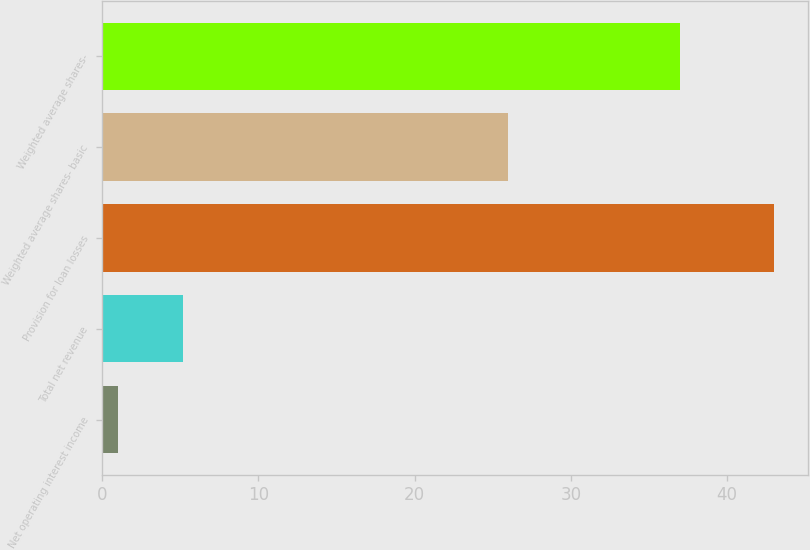Convert chart to OTSL. <chart><loc_0><loc_0><loc_500><loc_500><bar_chart><fcel>Net operating interest income<fcel>Total net revenue<fcel>Provision for loan losses<fcel>Weighted average shares- basic<fcel>Weighted average shares-<nl><fcel>1<fcel>5.2<fcel>43<fcel>26<fcel>37<nl></chart> 